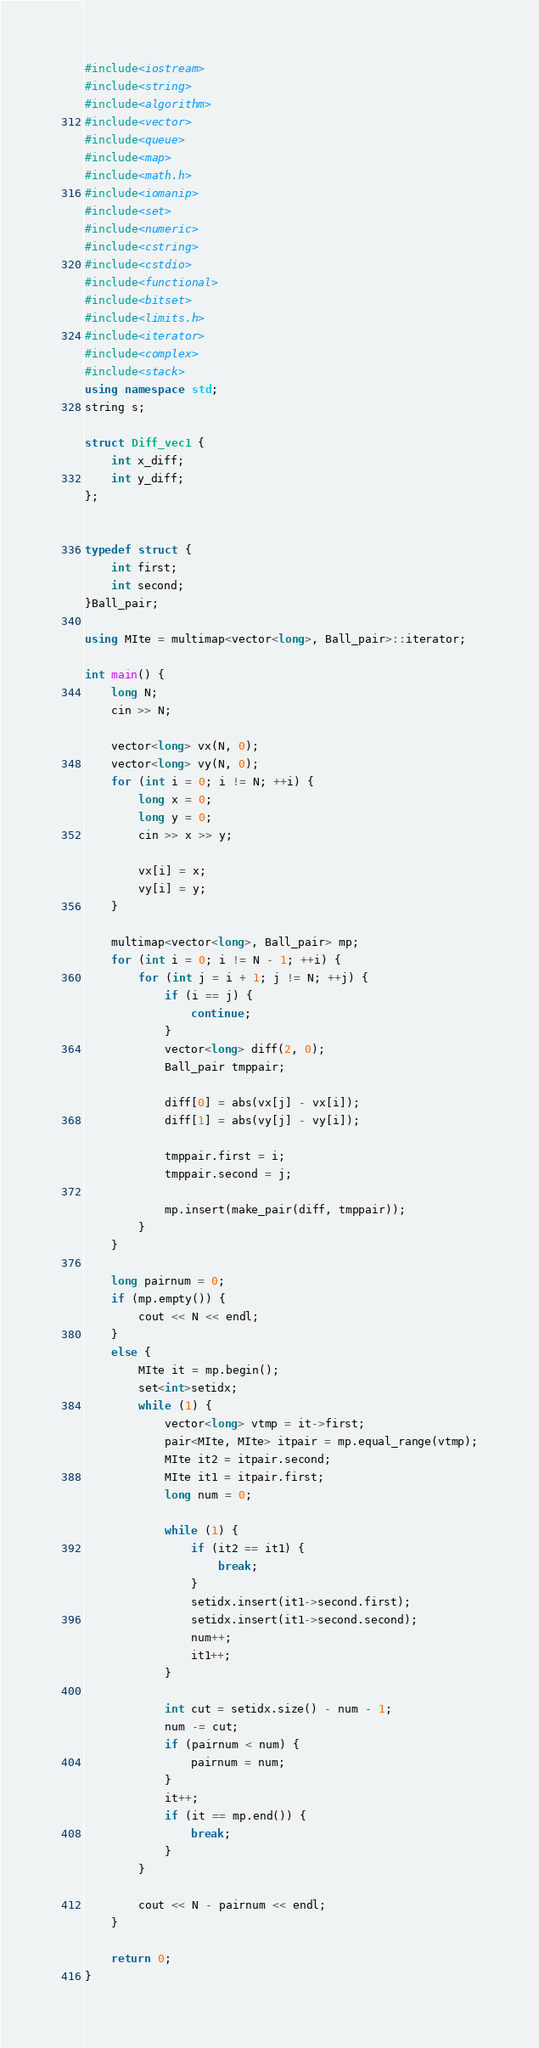<code> <loc_0><loc_0><loc_500><loc_500><_C++_>#include<iostream>
#include<string>
#include<algorithm>
#include<vector>
#include<queue>
#include<map>
#include<math.h>
#include<iomanip>
#include<set>
#include<numeric>
#include<cstring>
#include<cstdio>
#include<functional>
#include<bitset>
#include<limits.h>
#include<iterator>
#include<complex>
#include<stack>
using namespace std;
string s;

struct Diff_vec1 {
	int x_diff;
	int y_diff;
};


typedef struct {
	int first;
	int second;
}Ball_pair;

using MIte = multimap<vector<long>, Ball_pair>::iterator;

int main() {
	long N;
	cin >> N;

	vector<long> vx(N, 0);
	vector<long> vy(N, 0);
	for (int i = 0; i != N; ++i) {
		long x = 0;
		long y = 0;
		cin >> x >> y;

		vx[i] = x;
		vy[i] = y;
	}

	multimap<vector<long>, Ball_pair> mp;
	for (int i = 0; i != N - 1; ++i) {
		for (int j = i + 1; j != N; ++j) {
			if (i == j) {
				continue;
			}
			vector<long> diff(2, 0);
			Ball_pair tmppair;

			diff[0] = abs(vx[j] - vx[i]);
			diff[1] = abs(vy[j] - vy[i]);

			tmppair.first = i;
			tmppair.second = j;

			mp.insert(make_pair(diff, tmppair));
		}
	}

	long pairnum = 0;
	if (mp.empty()) {
		cout << N << endl;
	}
	else {
		MIte it = mp.begin();
		set<int>setidx;
		while (1) {
			vector<long> vtmp = it->first;
			pair<MIte, MIte> itpair = mp.equal_range(vtmp);
			MIte it2 = itpair.second;
			MIte it1 = itpair.first;
			long num = 0;

			while (1) {
				if (it2 == it1) {
					break;
				}
				setidx.insert(it1->second.first);
				setidx.insert(it1->second.second);
				num++;
				it1++;
			}

			int cut = setidx.size() - num - 1;
			num -= cut;
			if (pairnum < num) {
				pairnum = num;
			}
			it++;
			if (it == mp.end()) {
				break;
			}
		}

		cout << N - pairnum << endl;
	}

	return 0;
}</code> 